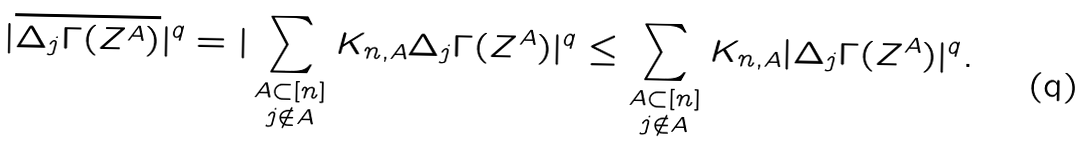<formula> <loc_0><loc_0><loc_500><loc_500>| \overline { \Delta _ { j } \Gamma ( Z ^ { A } ) } | ^ { q } = | \sum _ { \substack { A \subset [ n ] \\ j \notin A } } K _ { n , A } \Delta _ { j } \Gamma ( Z ^ { A } ) | ^ { q } \leq \sum _ { \substack { A \subset [ n ] \\ j \notin A } } K _ { n , A } | \Delta _ { j } \Gamma ( Z ^ { A } ) | ^ { q } .</formula> 